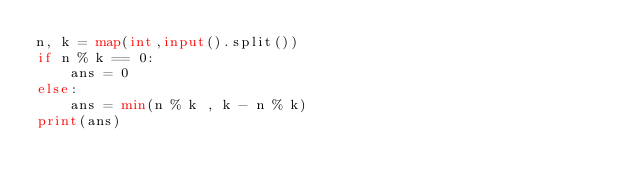Convert code to text. <code><loc_0><loc_0><loc_500><loc_500><_Python_>n, k = map(int,input().split())
if n % k == 0:
    ans = 0
else:
    ans = min(n % k , k - n % k)
print(ans)</code> 